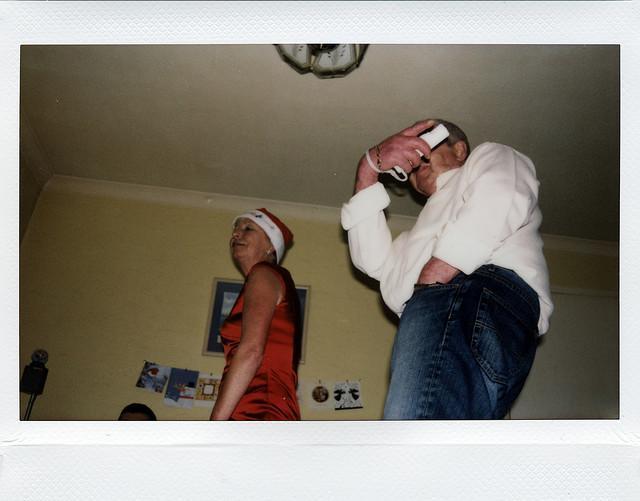What is the woman wearing on her head?
Indicate the correct response by choosing from the four available options to answer the question.
Options: Baseball cap, bandana, straw hat, headband. Headband. 